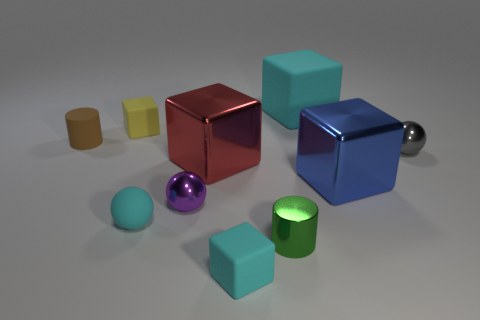Assuming these objects are part of a decorative set, how might they enhance the aesthetics of a room? Their vibrant colors and simple geometric shapes can add a touch of modernity and playfulness to a space. Arranged thoughtfully on a shelf or desk, they can provide visual interest and serve as a conversation starter. 